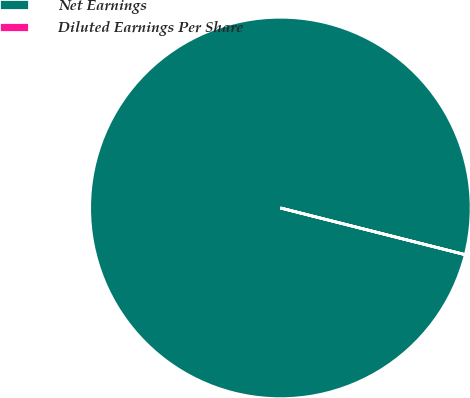Convert chart. <chart><loc_0><loc_0><loc_500><loc_500><pie_chart><fcel>Net Earnings<fcel>Diluted Earnings Per Share<nl><fcel>100.0%<fcel>0.0%<nl></chart> 